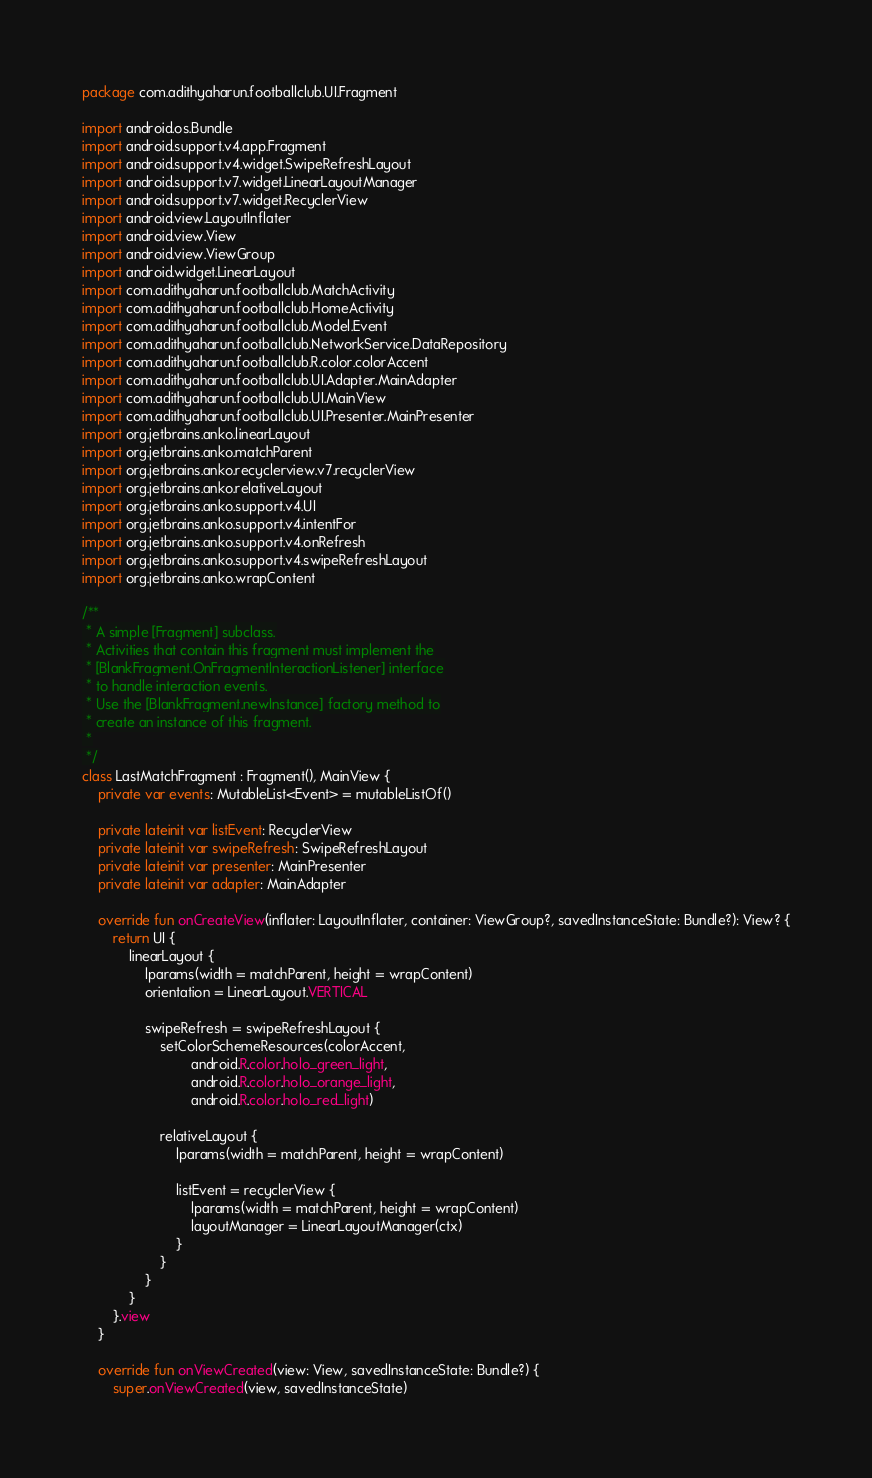Convert code to text. <code><loc_0><loc_0><loc_500><loc_500><_Kotlin_>package com.adithyaharun.footballclub.UI.Fragment

import android.os.Bundle
import android.support.v4.app.Fragment
import android.support.v4.widget.SwipeRefreshLayout
import android.support.v7.widget.LinearLayoutManager
import android.support.v7.widget.RecyclerView
import android.view.LayoutInflater
import android.view.View
import android.view.ViewGroup
import android.widget.LinearLayout
import com.adithyaharun.footballclub.MatchActivity
import com.adithyaharun.footballclub.HomeActivity
import com.adithyaharun.footballclub.Model.Event
import com.adithyaharun.footballclub.NetworkService.DataRepository
import com.adithyaharun.footballclub.R.color.colorAccent
import com.adithyaharun.footballclub.UI.Adapter.MainAdapter
import com.adithyaharun.footballclub.UI.MainView
import com.adithyaharun.footballclub.UI.Presenter.MainPresenter
import org.jetbrains.anko.linearLayout
import org.jetbrains.anko.matchParent
import org.jetbrains.anko.recyclerview.v7.recyclerView
import org.jetbrains.anko.relativeLayout
import org.jetbrains.anko.support.v4.UI
import org.jetbrains.anko.support.v4.intentFor
import org.jetbrains.anko.support.v4.onRefresh
import org.jetbrains.anko.support.v4.swipeRefreshLayout
import org.jetbrains.anko.wrapContent

/**
 * A simple [Fragment] subclass.
 * Activities that contain this fragment must implement the
 * [BlankFragment.OnFragmentInteractionListener] interface
 * to handle interaction events.
 * Use the [BlankFragment.newInstance] factory method to
 * create an instance of this fragment.
 *
 */
class LastMatchFragment : Fragment(), MainView {
    private var events: MutableList<Event> = mutableListOf()

    private lateinit var listEvent: RecyclerView
    private lateinit var swipeRefresh: SwipeRefreshLayout
    private lateinit var presenter: MainPresenter
    private lateinit var adapter: MainAdapter

    override fun onCreateView(inflater: LayoutInflater, container: ViewGroup?, savedInstanceState: Bundle?): View? {
        return UI {
            linearLayout {
                lparams(width = matchParent, height = wrapContent)
                orientation = LinearLayout.VERTICAL

                swipeRefresh = swipeRefreshLayout {
                    setColorSchemeResources(colorAccent,
                            android.R.color.holo_green_light,
                            android.R.color.holo_orange_light,
                            android.R.color.holo_red_light)

                    relativeLayout {
                        lparams(width = matchParent, height = wrapContent)

                        listEvent = recyclerView {
                            lparams(width = matchParent, height = wrapContent)
                            layoutManager = LinearLayoutManager(ctx)
                        }
                    }
                }
            }
        }.view
    }

    override fun onViewCreated(view: View, savedInstanceState: Bundle?) {
        super.onViewCreated(view, savedInstanceState)
</code> 